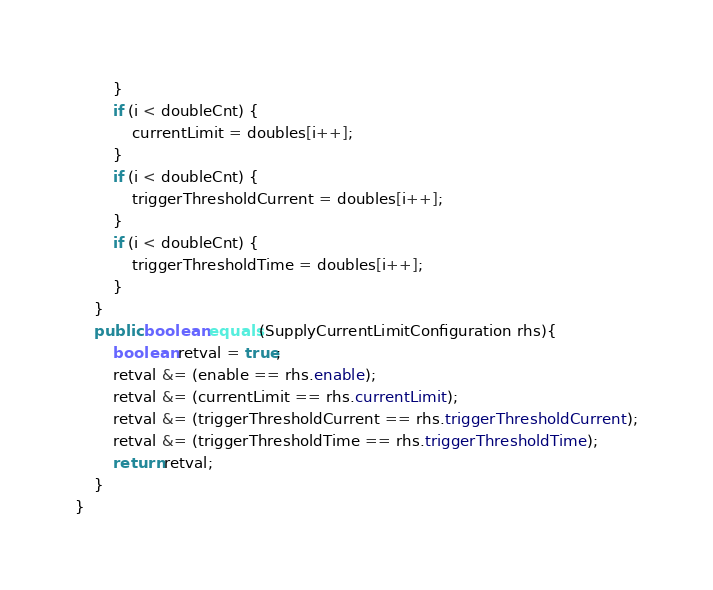<code> <loc_0><loc_0><loc_500><loc_500><_Java_>        }
        if (i < doubleCnt) {
            currentLimit = doubles[i++];
        }
        if (i < doubleCnt) {
            triggerThresholdCurrent = doubles[i++];
        }
        if (i < doubleCnt) {
            triggerThresholdTime = doubles[i++];
        }
    }
    public boolean equals(SupplyCurrentLimitConfiguration rhs){
        boolean retval = true;
        retval &= (enable == rhs.enable);
        retval &= (currentLimit == rhs.currentLimit);
        retval &= (triggerThresholdCurrent == rhs.triggerThresholdCurrent);
        retval &= (triggerThresholdTime == rhs.triggerThresholdTime);
        return retval;
    }
}</code> 